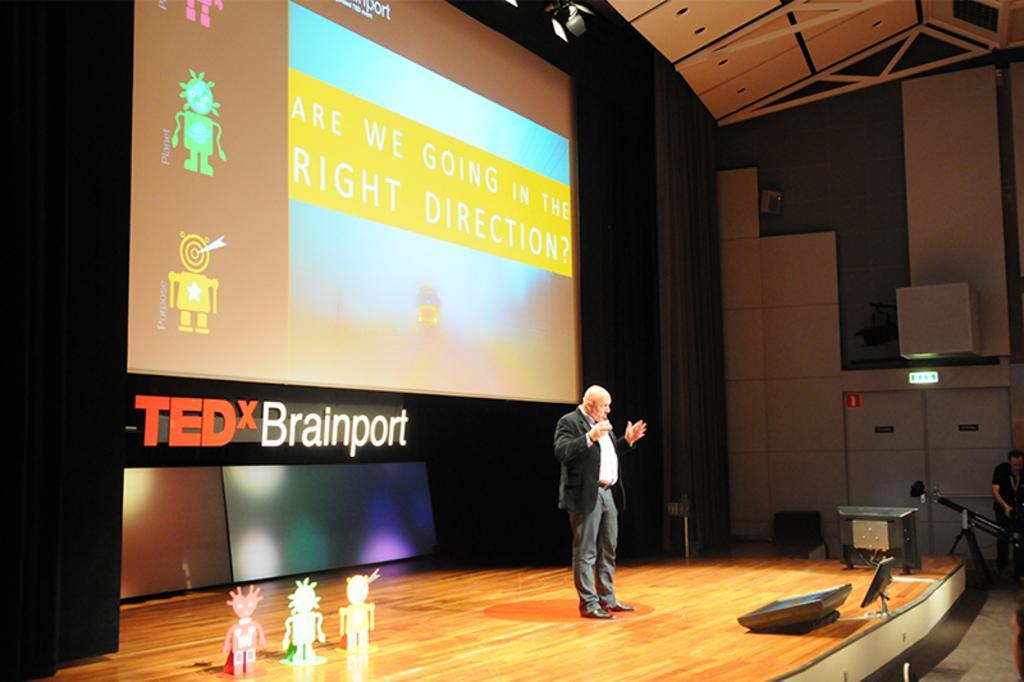How would you summarize this image in a sentence or two? In this image I can see a person wearing white shirt, black blazer and grey pant is standing on the stage. I can see few toys on the stage. In the background I can see a huge screen, few lights, the ceiling and few other objects. To the right side of the image I can see a person wearing black dress is stunning. 